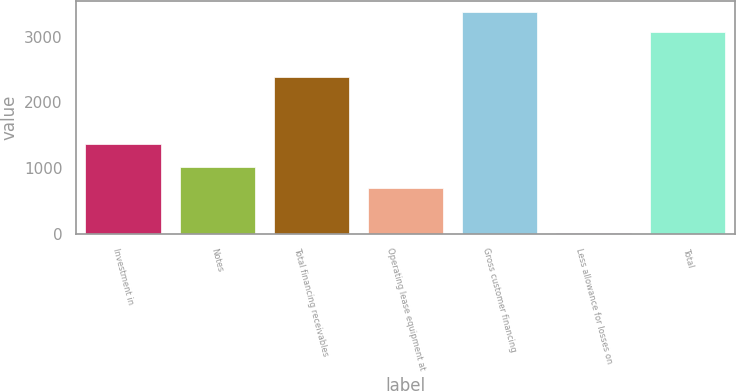Convert chart to OTSL. <chart><loc_0><loc_0><loc_500><loc_500><bar_chart><fcel>Investment in<fcel>Notes<fcel>Total financing receivables<fcel>Operating lease equipment at<fcel>Gross customer financing<fcel>Less allowance for losses on<fcel>Total<nl><fcel>1364<fcel>1022<fcel>2386<fcel>691<fcel>3371.5<fcel>12<fcel>3065<nl></chart> 